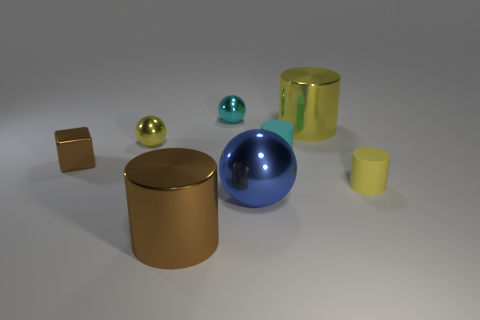Subtract all cyan metallic balls. How many balls are left? 2 Add 1 tiny things. How many objects exist? 9 Subtract all blocks. How many objects are left? 7 Subtract 3 cylinders. How many cylinders are left? 1 Subtract all cyan cylinders. How many cylinders are left? 3 Add 4 rubber objects. How many rubber objects exist? 6 Subtract 0 green cylinders. How many objects are left? 8 Subtract all blue cubes. Subtract all cyan cylinders. How many cubes are left? 1 Subtract all green balls. How many cyan cylinders are left? 1 Subtract all small cubes. Subtract all large cylinders. How many objects are left? 5 